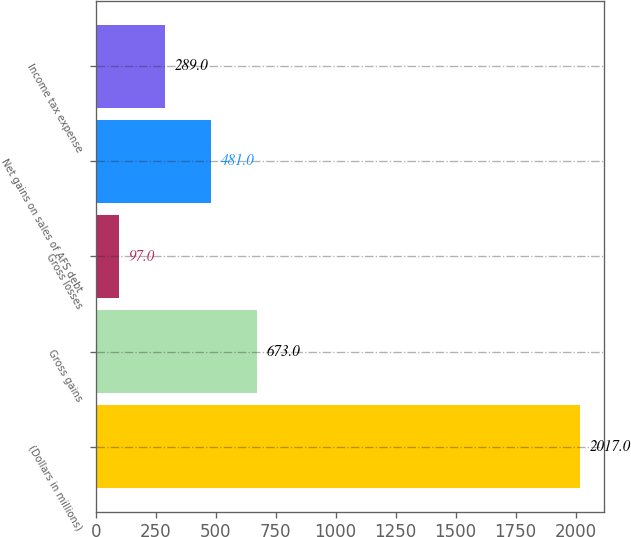Convert chart to OTSL. <chart><loc_0><loc_0><loc_500><loc_500><bar_chart><fcel>(Dollars in millions)<fcel>Gross gains<fcel>Gross losses<fcel>Net gains on sales of AFS debt<fcel>Income tax expense<nl><fcel>2017<fcel>673<fcel>97<fcel>481<fcel>289<nl></chart> 